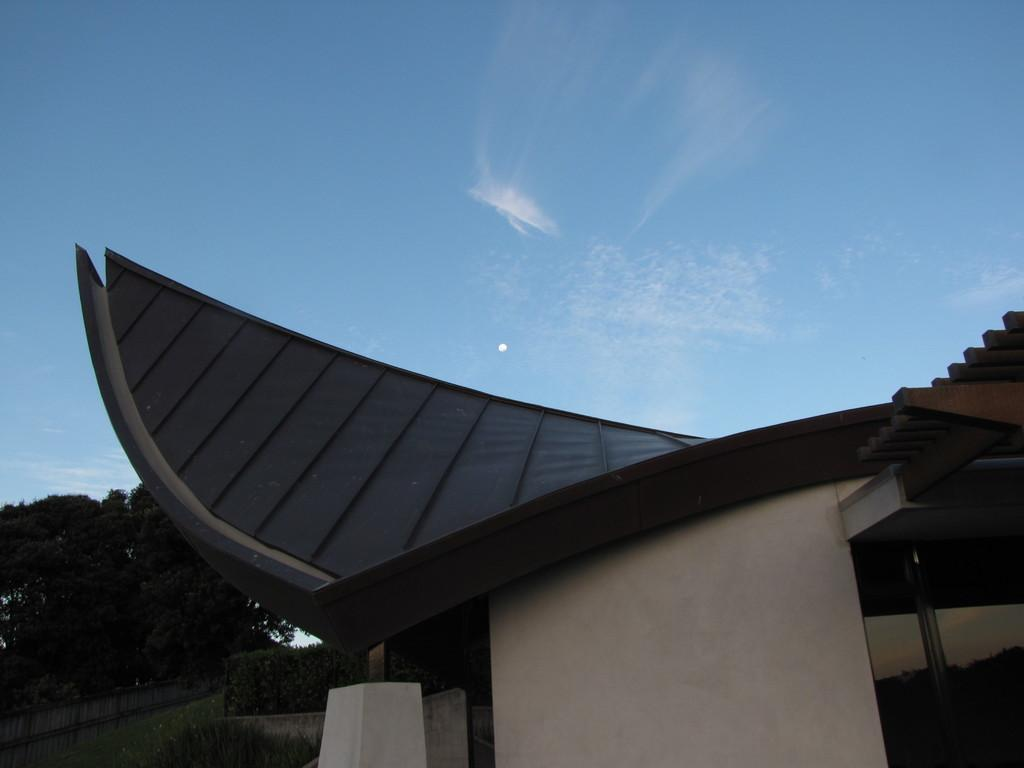What type of vegetation is at the bottom of the image? There is grass at the bottom of the image. What can be seen in the background of the image? There are trees in the background of the image. What type of structure is visible in the image? There is a building visible in the image. What is visible at the top of the image? The sky is visible at the top of the image. How does the hope affect the fog in the image? There is no mention of hope or fog in the image; it only features grass, trees, a building, and the sky. 